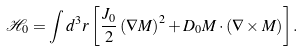<formula> <loc_0><loc_0><loc_500><loc_500>\mathcal { H } _ { 0 } = \int d ^ { 3 } r \left [ \frac { J _ { 0 } } { 2 } \left ( \nabla M \right ) ^ { 2 } + D _ { 0 } M \cdot \left ( \nabla \times M \right ) \right ] .</formula> 